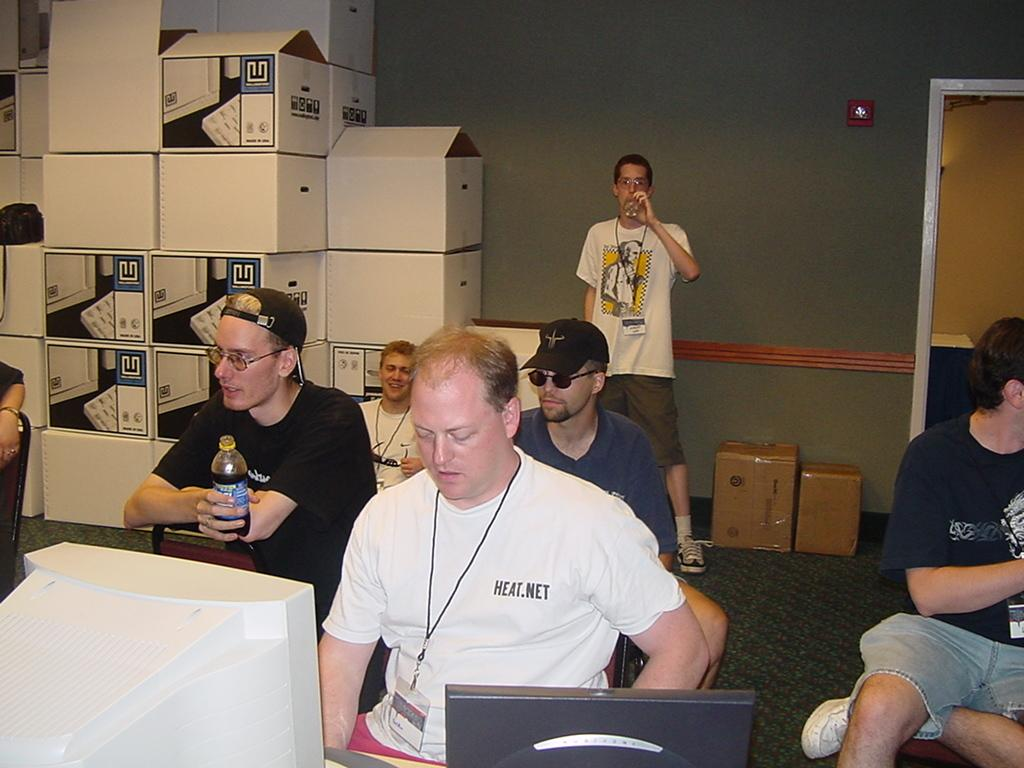What are the people in the image doing? There is a group of people sitting on chairs in the image. What is the position of the man in the image? There is a man standing on the floor in the image. What objects can be seen in the image besides the people and the man? There are boxes and monitors in the image. What is visible in the background of the image? There is a wall in the background of the image. How many children are playing with the sheep in the image? There are no children or sheep present in the image. What type of fly is buzzing around the man in the image? There is no fly present in the image. 